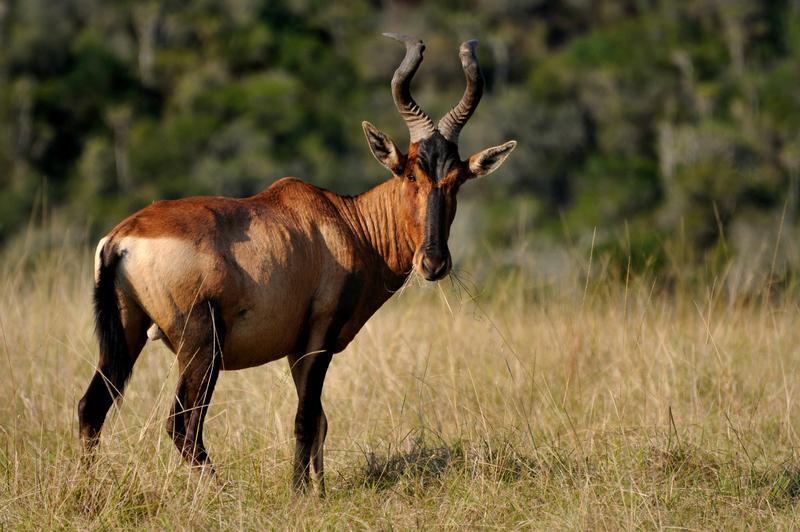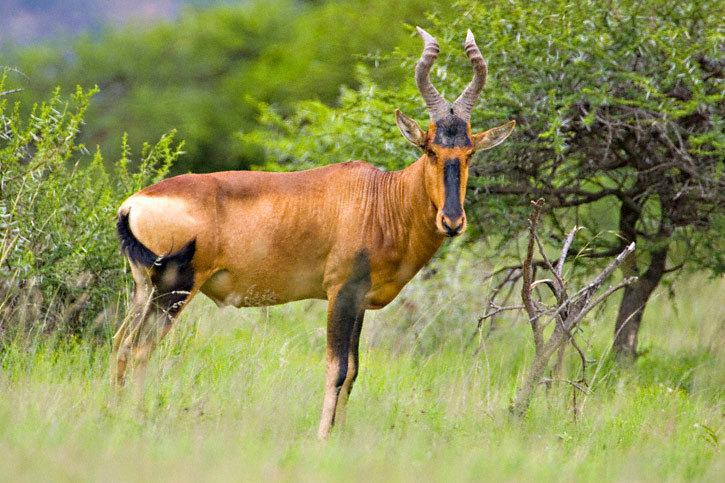The first image is the image on the left, the second image is the image on the right. For the images shown, is this caption "In one of the images, there is an animal near water." true? Answer yes or no. No. The first image is the image on the left, the second image is the image on the right. Assess this claim about the two images: "There are exactly two horned animals standing in total.". Correct or not? Answer yes or no. Yes. 